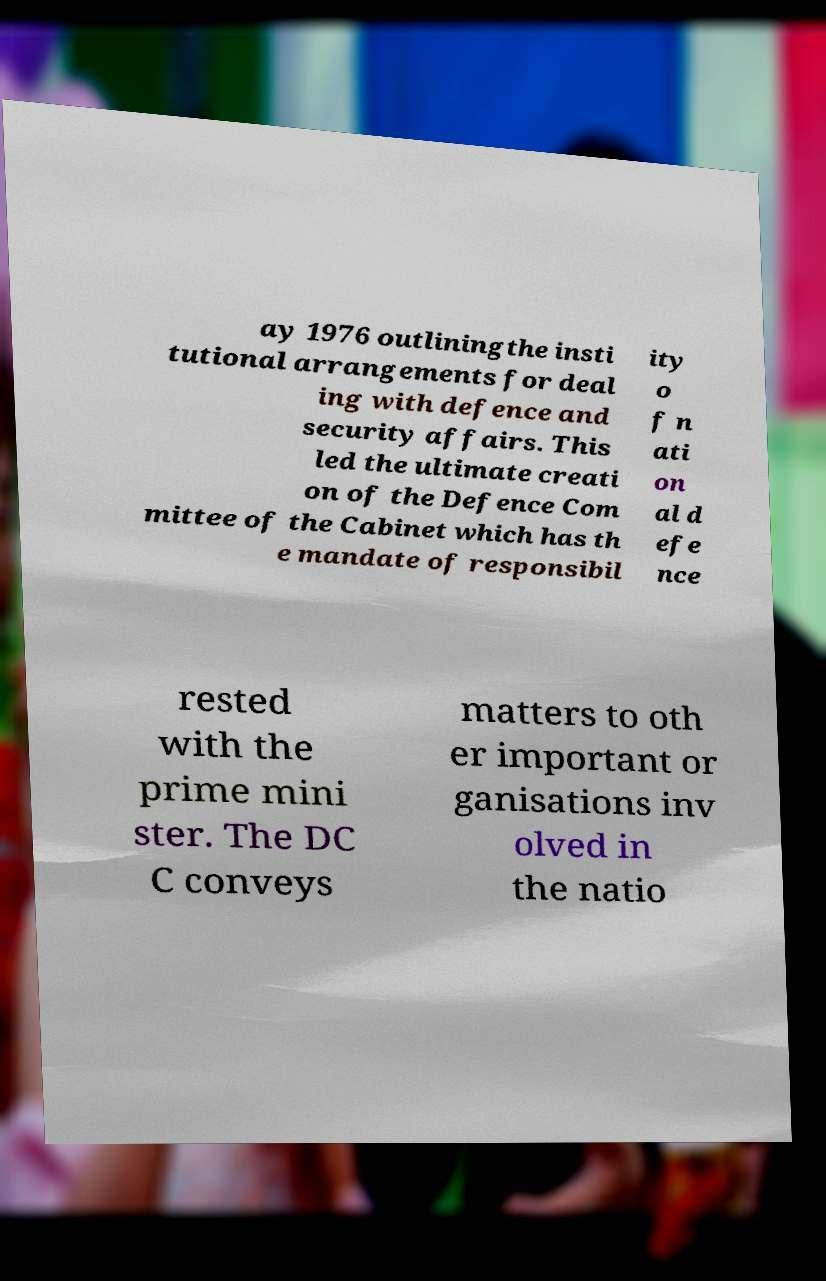Please identify and transcribe the text found in this image. ay 1976 outliningthe insti tutional arrangements for deal ing with defence and security affairs. This led the ultimate creati on of the Defence Com mittee of the Cabinet which has th e mandate of responsibil ity o f n ati on al d efe nce rested with the prime mini ster. The DC C conveys matters to oth er important or ganisations inv olved in the natio 